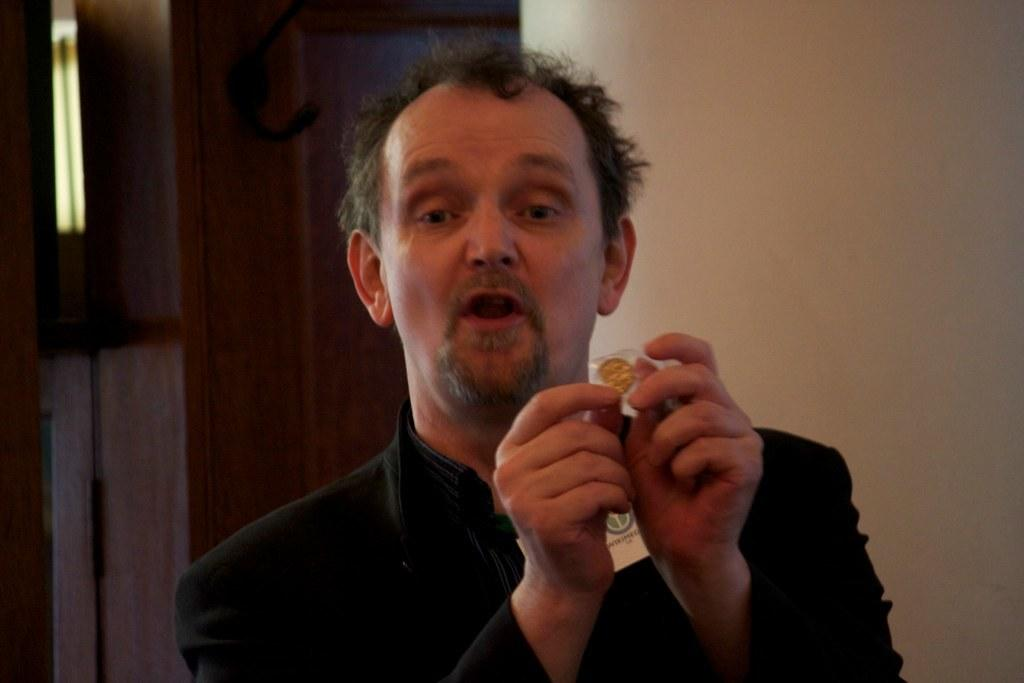Who is present in the image? There is a man in the image. What is the man wearing? The man is wearing a black dress. What is the man holding in the image? The man is holding an object. How many people are guiding the man in the image? There is no indication in the image that the man is being guided by anyone. What type of person is standing next to the man in the image? There is no other person present in the image besides the man. What day of the week is depicted in the image? The image does not provide any information about the day of the week. 